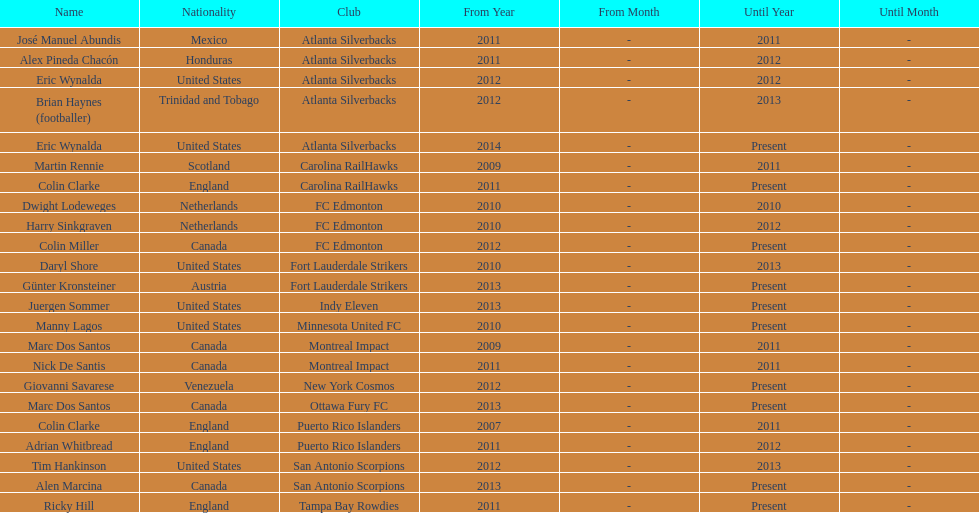Who is the last to coach the san antonio scorpions? Alen Marcina. 